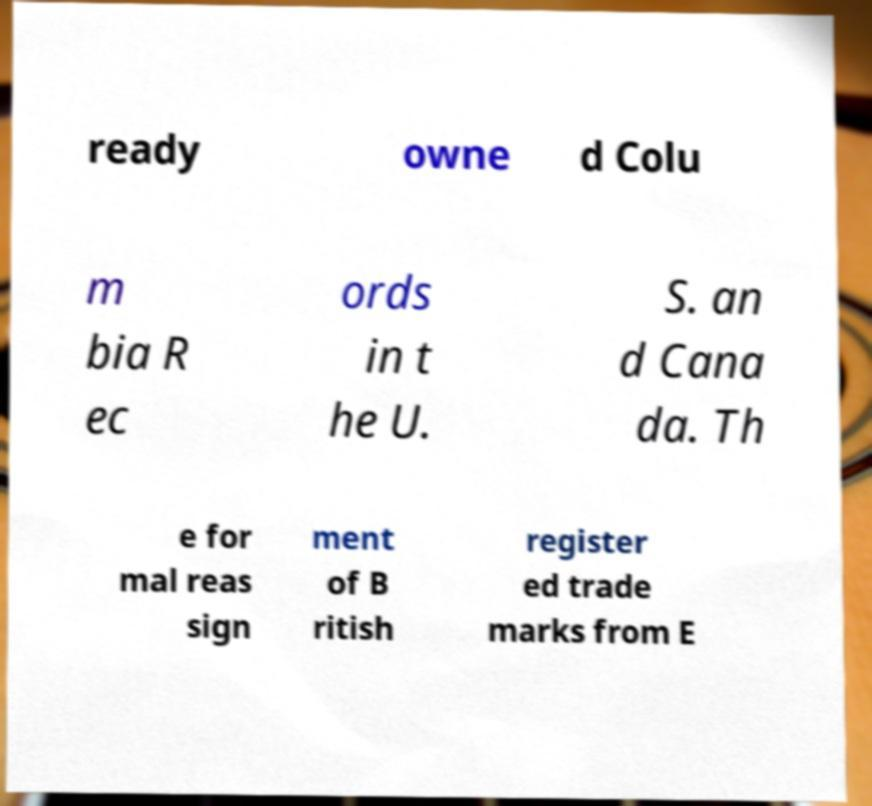Can you read and provide the text displayed in the image?This photo seems to have some interesting text. Can you extract and type it out for me? ready owne d Colu m bia R ec ords in t he U. S. an d Cana da. Th e for mal reas sign ment of B ritish register ed trade marks from E 